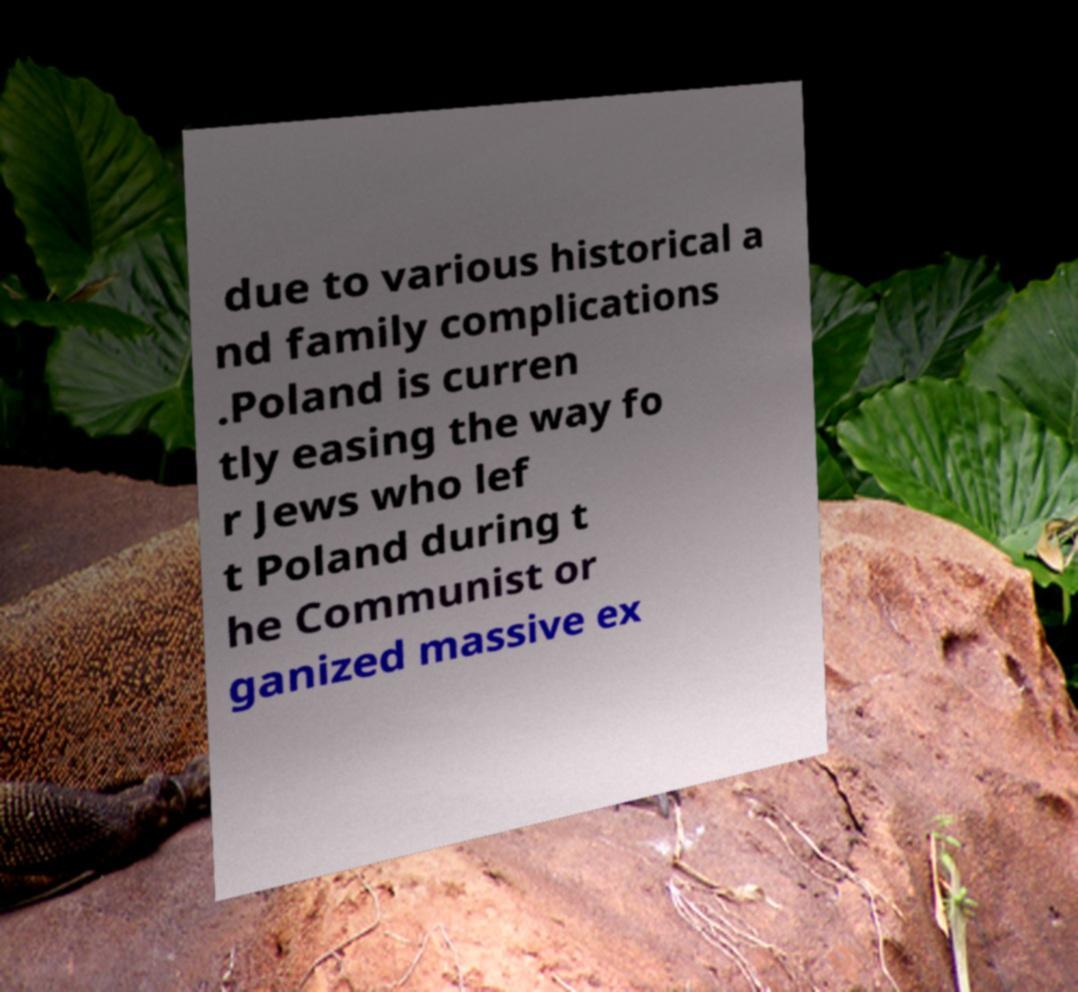Please identify and transcribe the text found in this image. due to various historical a nd family complications .Poland is curren tly easing the way fo r Jews who lef t Poland during t he Communist or ganized massive ex 